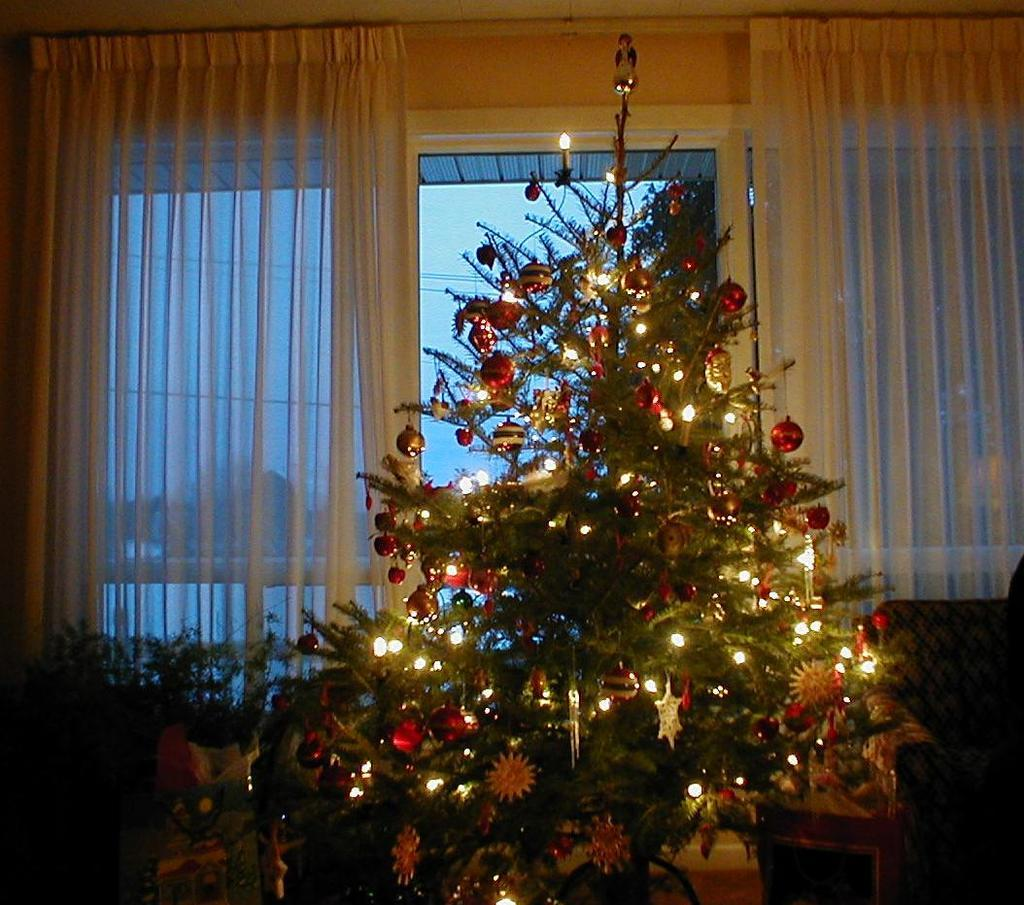What type of tree is in the image? There is a Christmas tree in the image. What can be seen through the window in the image? The presence of a window suggests that something is visible through it, but the facts provided do not specify what that might be. What type of window treatment is present in the image? There are curtains associated with the window in the image. What type of locket is hanging from the Christmas tree in the image? There is no locket present on the Christmas tree in the image. 